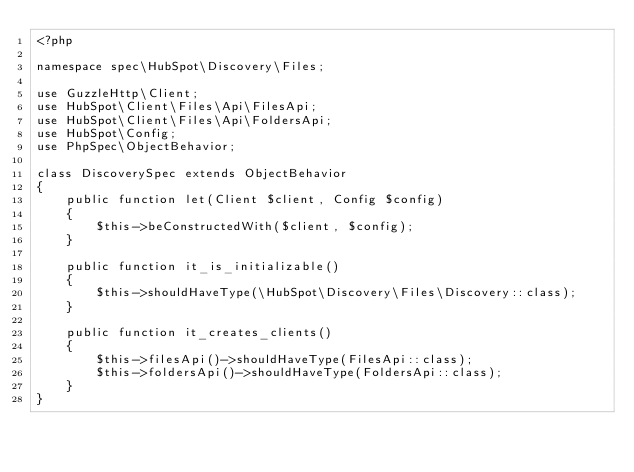<code> <loc_0><loc_0><loc_500><loc_500><_PHP_><?php

namespace spec\HubSpot\Discovery\Files;

use GuzzleHttp\Client;
use HubSpot\Client\Files\Api\FilesApi;
use HubSpot\Client\Files\Api\FoldersApi;
use HubSpot\Config;
use PhpSpec\ObjectBehavior;

class DiscoverySpec extends ObjectBehavior
{
    public function let(Client $client, Config $config)
    {
        $this->beConstructedWith($client, $config);
    }

    public function it_is_initializable()
    {
        $this->shouldHaveType(\HubSpot\Discovery\Files\Discovery::class);
    }

    public function it_creates_clients()
    {
        $this->filesApi()->shouldHaveType(FilesApi::class);
        $this->foldersApi()->shouldHaveType(FoldersApi::class);
    }
}
</code> 